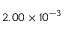<formula> <loc_0><loc_0><loc_500><loc_500>2 . 0 0 \times 1 0 ^ { - 3 }</formula> 